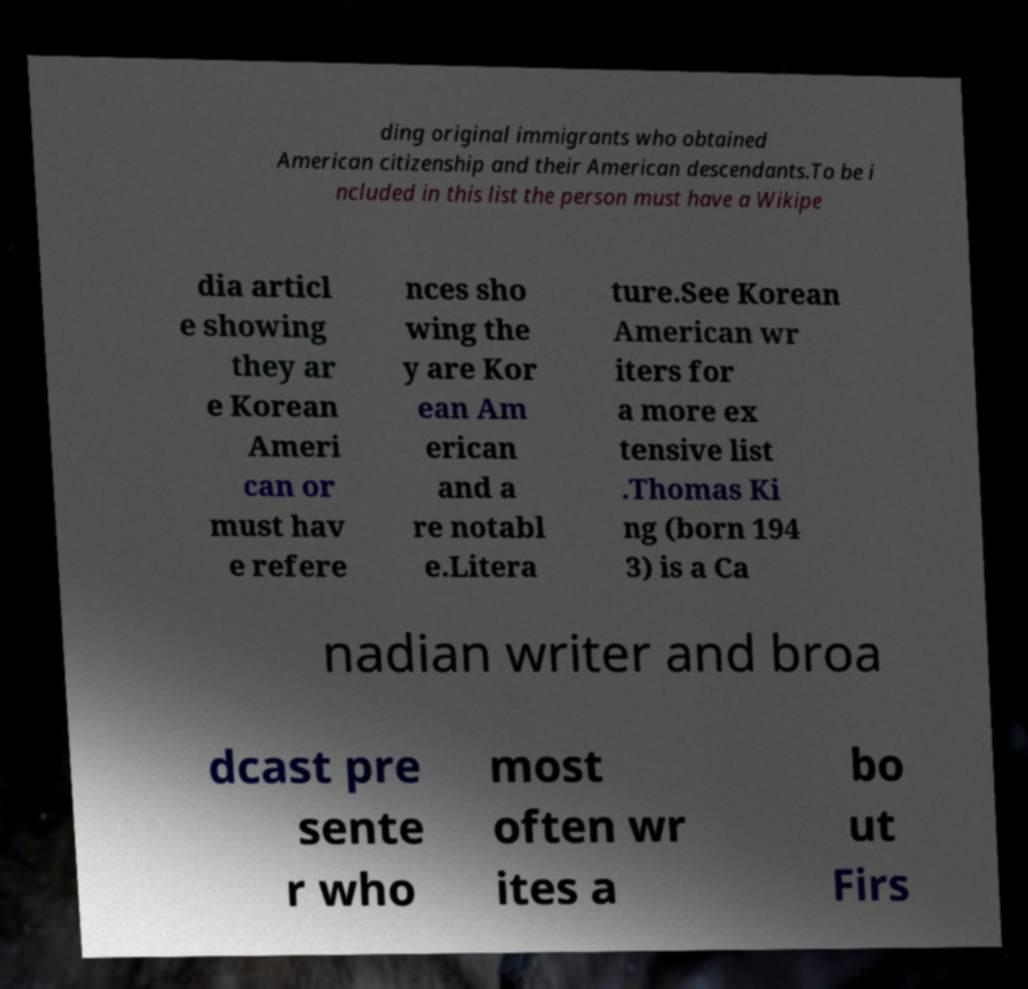I need the written content from this picture converted into text. Can you do that? ding original immigrants who obtained American citizenship and their American descendants.To be i ncluded in this list the person must have a Wikipe dia articl e showing they ar e Korean Ameri can or must hav e refere nces sho wing the y are Kor ean Am erican and a re notabl e.Litera ture.See Korean American wr iters for a more ex tensive list .Thomas Ki ng (born 194 3) is a Ca nadian writer and broa dcast pre sente r who most often wr ites a bo ut Firs 